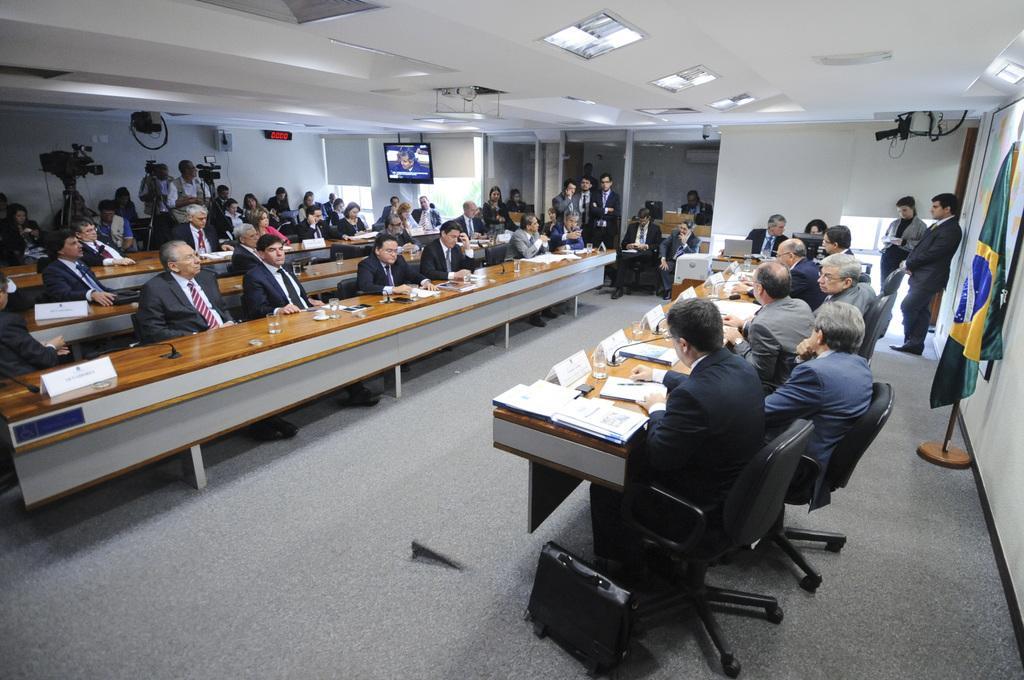Describe this image in one or two sentences. In the foreground of this image, on the right, there are few men sitting on the chairs in front of table on which there are books, files, mics and glasses. At the bottom, there is a black color bag on the floor. We can also see a flag, a board and few lights to the ceiling and two people standing. In the background, there are people sitting in desks, a screen on the wall, video cameras to the stands, wall, ceiling and few people standing near the glass wall. 